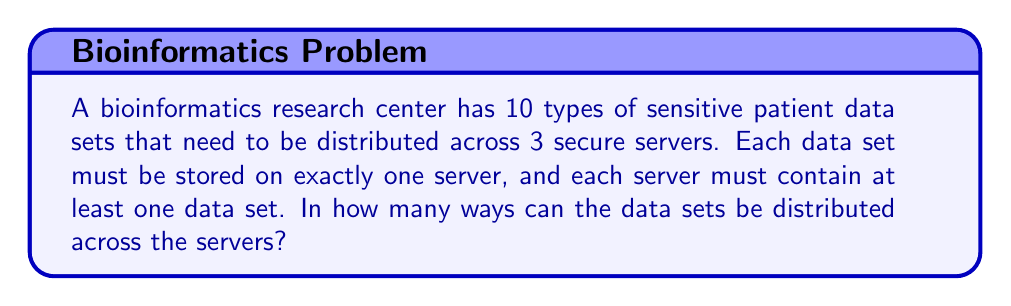Help me with this question. To solve this problem, we can use the concept of Stirling numbers of the second kind and the principle of inclusion-exclusion.

1) Let's denote $S(n,k)$ as the Stirling number of the second kind, which represents the number of ways to partition n distinct objects into k non-empty subsets.

2) In our case, we have n = 10 (data sets) and k = 3 (servers).

3) The formula for $S(n,k)$ is:

   $$S(n,k) = \frac{1}{k!}\sum_{i=0}^k (-1)^{k-i}\binom{k}{i}i^n$$

4) Substituting our values:

   $$S(10,3) = \frac{1}{3!}\sum_{i=0}^3 (-1)^{3-i}\binom{3}{i}i^{10}$$

5) Expanding this:

   $$S(10,3) = \frac{1}{6}[(3^{10}) - 3(2^{10}) + 3(1^{10}) - 0^{10}]$$

6) Calculating:
   
   $$S(10,3) = \frac{1}{6}[59049 - 3072 + 3 - 0] = 9330$$

7) However, this counts the number of ways to partition the data sets, not the number of ways to distribute them to specific servers.

8) To get the final answer, we need to multiply by the number of ways to arrange 3 groups, which is simply 3! = 6.

9) Therefore, the total number of ways is:

   $$9330 \times 6 = 55980$$
Answer: 55980 